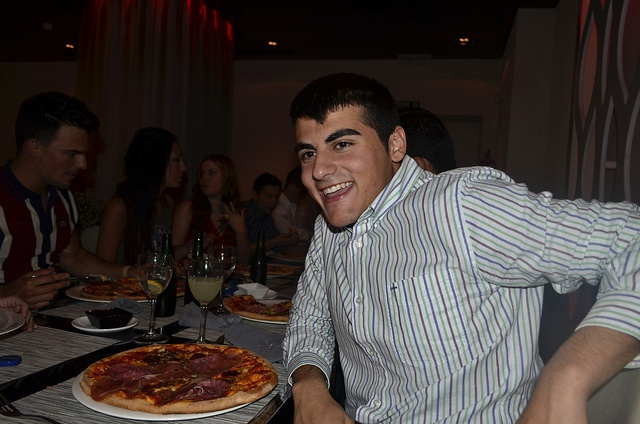Describe the objects in this image and their specific colors. I can see people in black, darkgray, and gray tones, dining table in black and gray tones, people in black and gray tones, pizza in black, maroon, brown, and gray tones, and people in black tones in this image. 